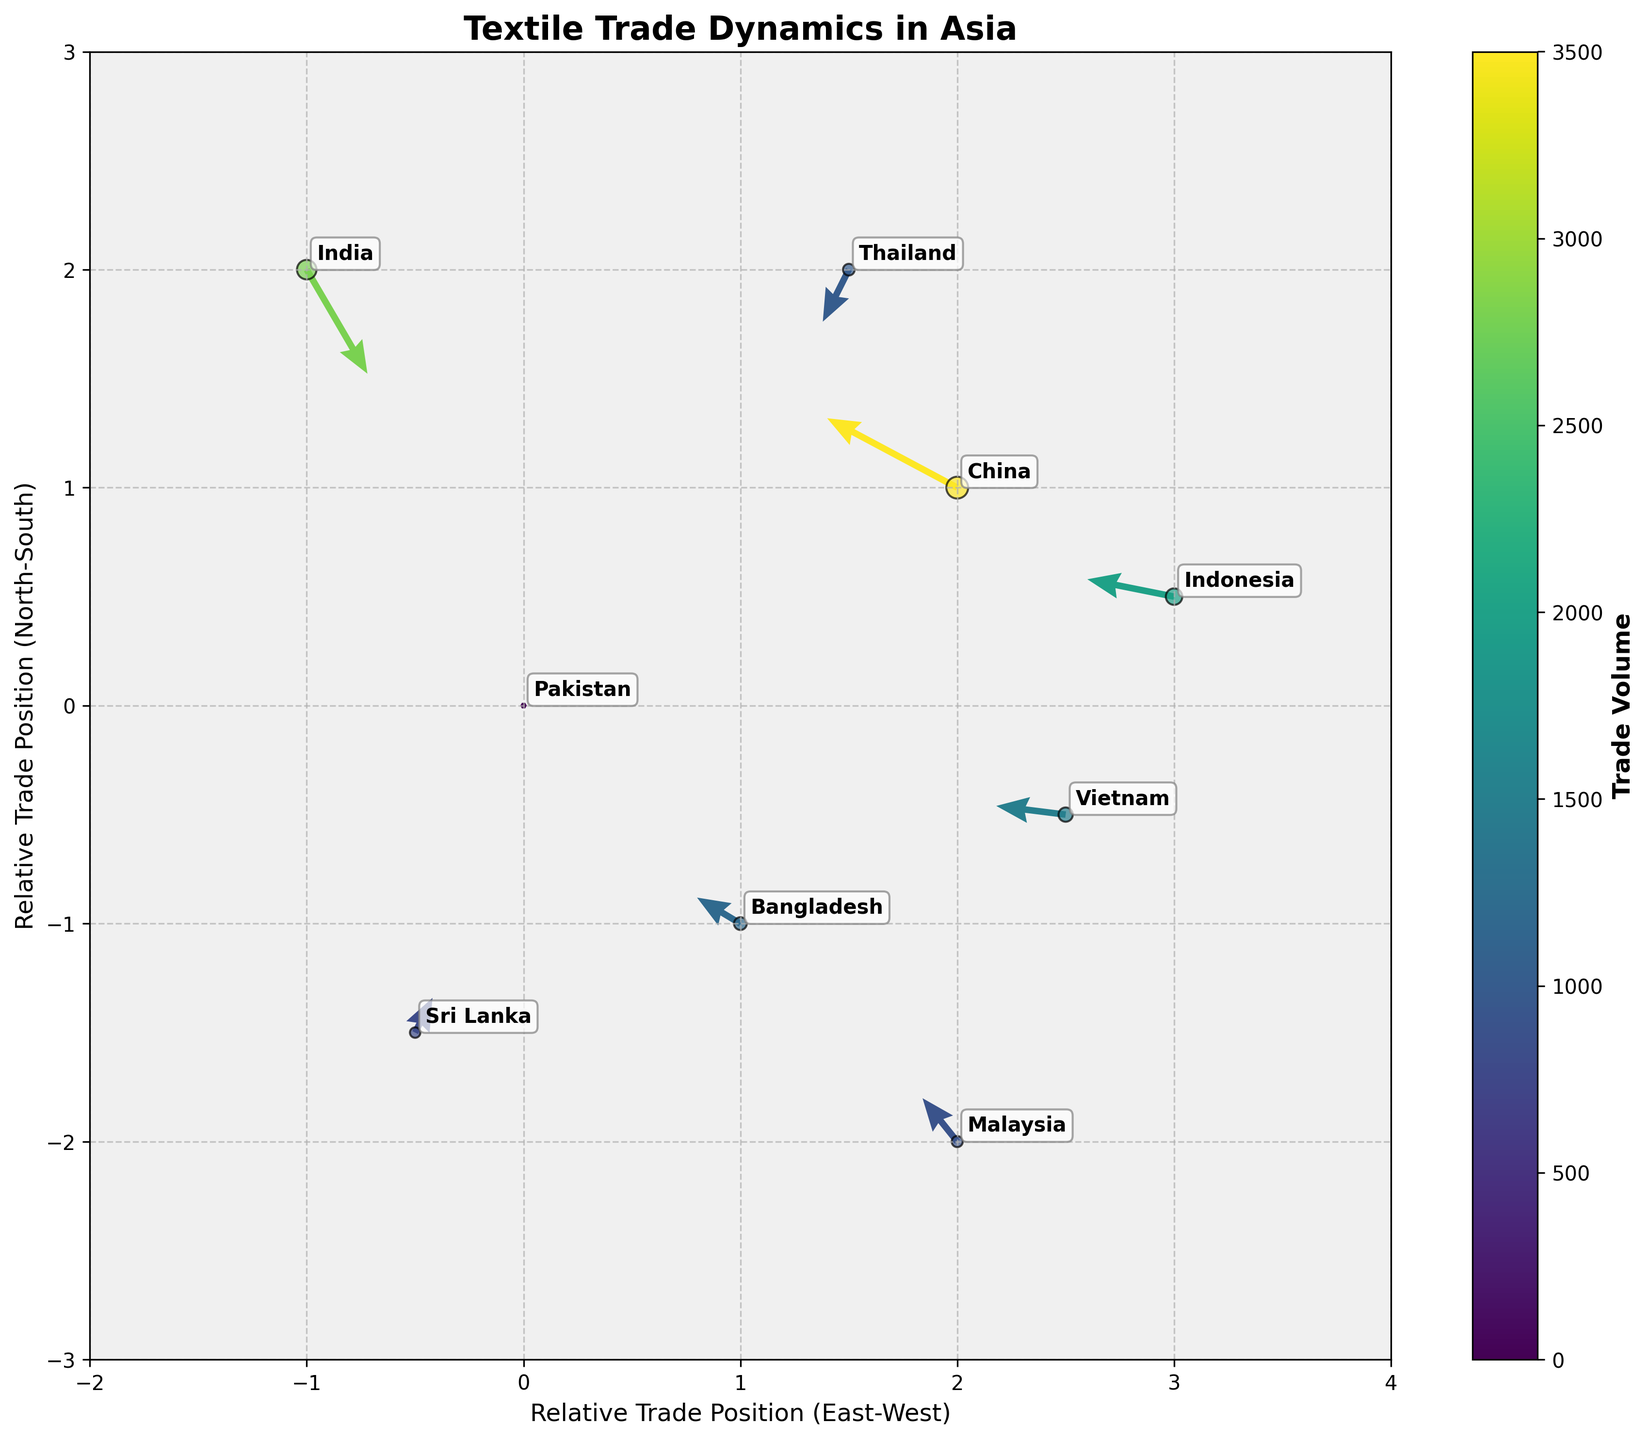What is the title of the plot? The title is usually placed at the top of the figure, and here it reads "Textile Trade Dynamics in Asia".
Answer: Textile Trade Dynamics in Asia How is the colorbar related to the plot? The colorbar next to the plot indicates the trade volume, as represented by the color of the arrows and scatter points. Darker colors correspond to higher trade volumes.
Answer: It shows trade volume Which country has the highest trade volume with Pakistan? The country with the darkest-colored arrow and scatter point indicates the highest trade volume. China has the darkest color.
Answer: China What is the trade direction between Pakistan and India? Look at the arrow pointing from Pakistan (0,0) towards India’s position. The arrow for India starts from (0,0) and ends at roughly (-0.3, 0.8). This suggests net export from Pakistan to India.
Answer: Export from Pakistan to India How many countries show net import from Pakistan, as indicated by arrows pointing towards Pakistan? Count the number of arrows that point towards the origin (0,0). Here only China's arrow is pointing towards Pakistan.
Answer: 1 country Which country's trade vector has the smallest magnitude? The smallest vectors are the shortest arrows. Visually, Sri Lanka's vector, despite a small trade volume, seems shortest.
Answer: Sri Lanka Which country is positioned most easterly relative to Pakistan? Identify the country with the highest positive X value. Vietnam is positioned at (2.5,-0.5).
Answer: Vietnam Which arrow indicates the most balanced trade in terms of direction (closest to being horizontal)? Balanced trade is indicated by vectors closest to the horizontal axis (smaller vertical component). The arrow for Indonesia (-1, 0.2) is closest to horizontal among others.
Answer: Indonesia What is the total trade volume across all countries shown? Sum up the trade volumes listed for all countries: 3500 + 2800 + 1200 + 800 + 1500 + 1000 + 2000 + 900 = 13700.
Answer: 13700 Between China and Bangladesh, which country has a stronger export to Pakistan? Compare the directions of the arrows from these two countries to Pakistan. Both are importing into Pakistan, but China’s arrow is longer than Bangladesh’s, indicating larger magnitude of import (export from China).
Answer: China 